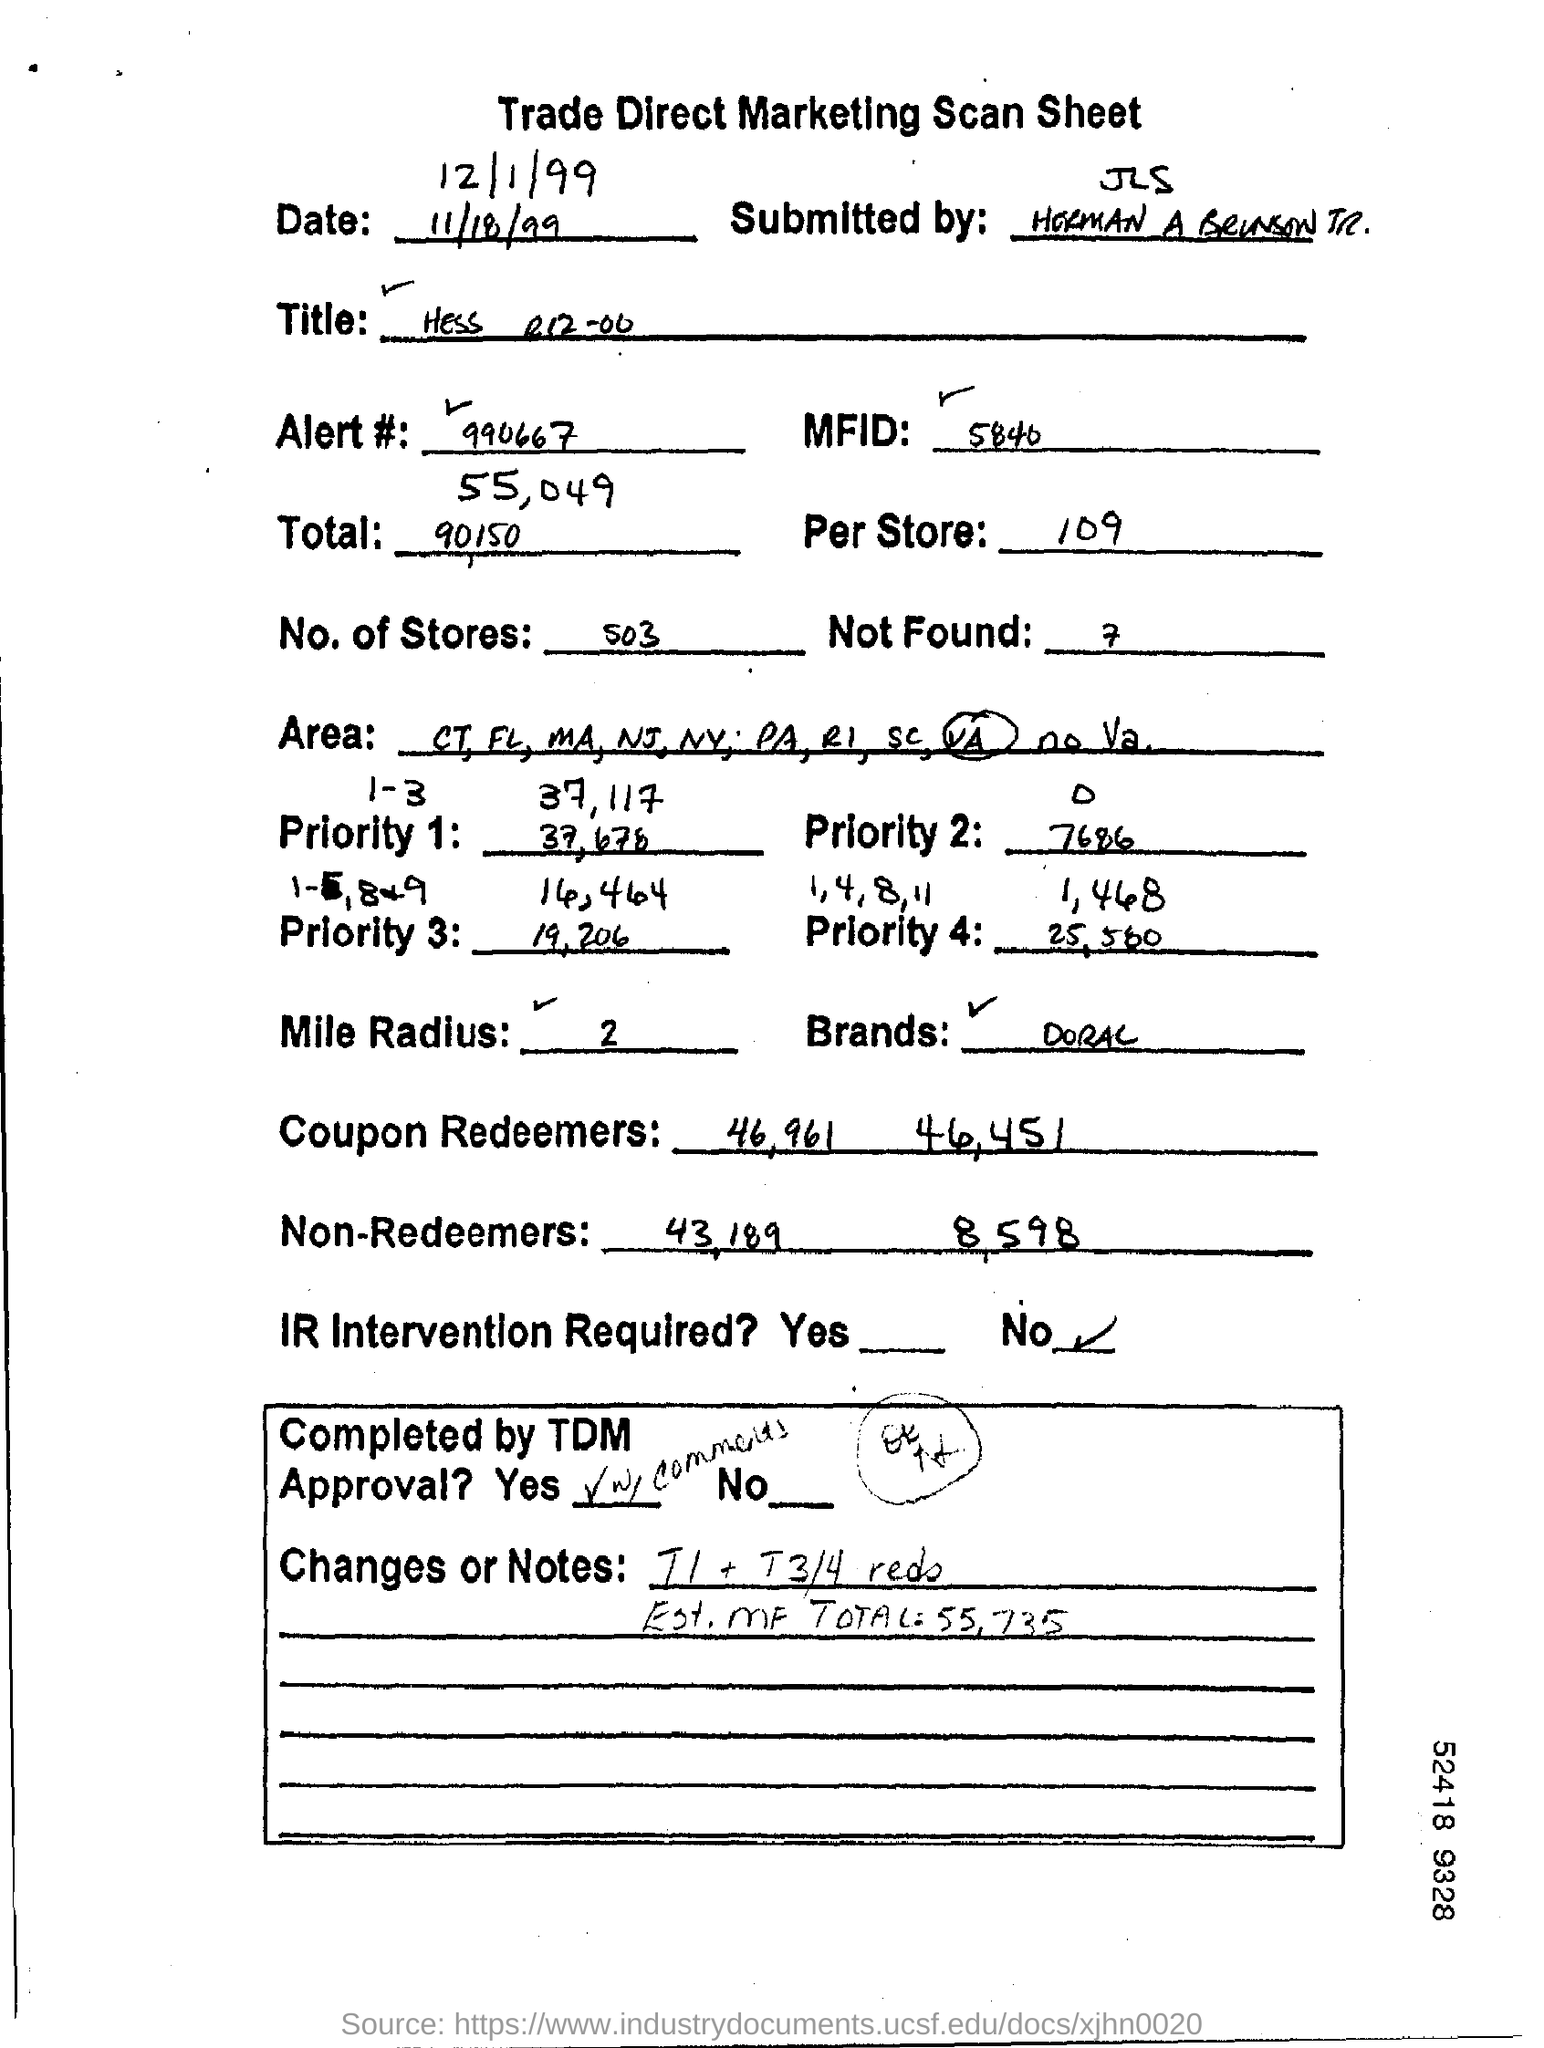What is the alert #?
Provide a short and direct response. 990667. How many no. of stores are there ?
Offer a terse response. 503. How many are not found ?
Your answer should be very brief. 7. Is the ir intervention required ?
Make the answer very short. No. What is the mile radius ?
Your answer should be very brief. 2. 